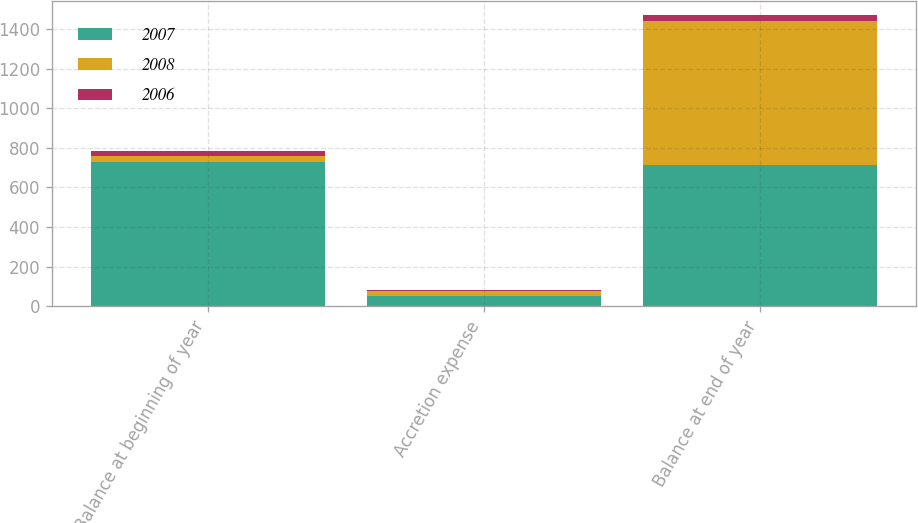<chart> <loc_0><loc_0><loc_500><loc_500><stacked_bar_chart><ecel><fcel>Balance at beginning of year<fcel>Accretion expense<fcel>Balance at end of year<nl><fcel>2007<fcel>728<fcel>51<fcel>712<nl><fcel>2008<fcel>30<fcel>27<fcel>728<nl><fcel>2006<fcel>27<fcel>3<fcel>30<nl></chart> 